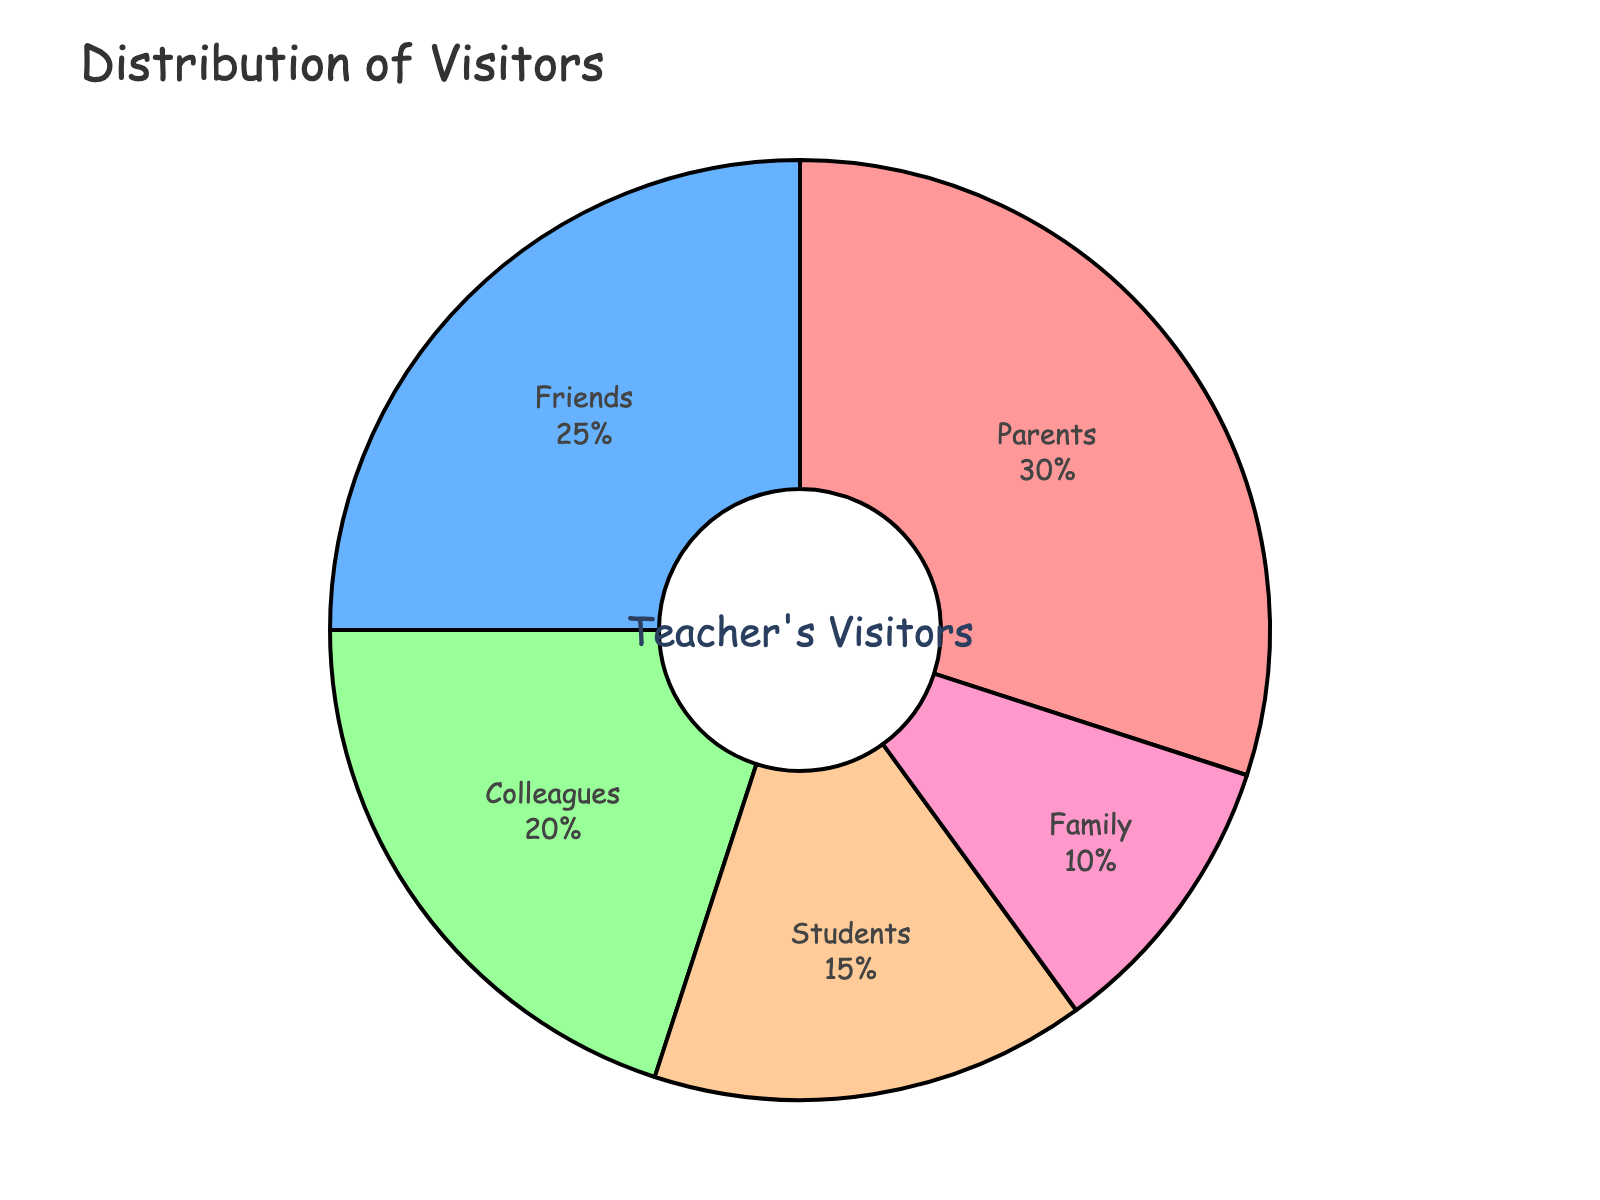What percentage of visitors are colleagues and friends combined? To find the combined percentage of colleagues and friends, add their individual percentages. Colleagues: 20%, Friends: 25%. 20% + 25% = 45%
Answer: 45% Are there more parents or students visiting the teacher? Compare the percentages of parents and students. Parents: 30%, Students: 15%. Since 30% > 15%, there are more parents visiting than students.
Answer: Parents Which group is the smallest in terms of the percentage of visitors? Identify the group with the lowest percentage. Students: 15%, Parents: 30%, Colleagues: 20%, Friends: 25%, Family: 10%. The smallest percentage is 10%, which is for Family.
Answer: Family What is the difference in the percentage of visitors between friends and family? Subtract the percentage of family visitors from the percentage of friends visitors. Friends: 25%, Family: 10%. 25% - 10% = 15%
Answer: 15% What color represents the student visitors in the pie chart? Identify the color associated with student visitors by looking at the pie chart's section labeled "Students." The color corresponding to "Students" is light red.
Answer: light red Which two groups together make up exactly half of the total visitors? Find two groups whose percentages sum to 50%. Parents: 30%, Colleagues: 20%. 30% + 20% = 50%. Therefore, Parents and Colleagues together make up half the total visitors.
Answer: Parents and Colleagues Is the percentage of friends visiting more or less than the sum of students and family visitors? Calculate the sum of the percentages of students and family. Students: 15%, Family: 10%. 15% + 10% = 25%. Compare it with the percentage of friends, which is 25%. Since 25% equals 25%, the percentage of friends visiting is equal to the sum of students and family visitors.
Answer: Equal What percentage of visitors are neither parents nor colleagues? Find the sum of the percentages of parents and colleagues and subtract from 100%. Parents: 30%, Colleagues: 20%. 30% + 20% = 50%. 100% - 50% = 50%. Therefore, 50% of visitors are neither parents nor colleagues.
Answer: 50% 